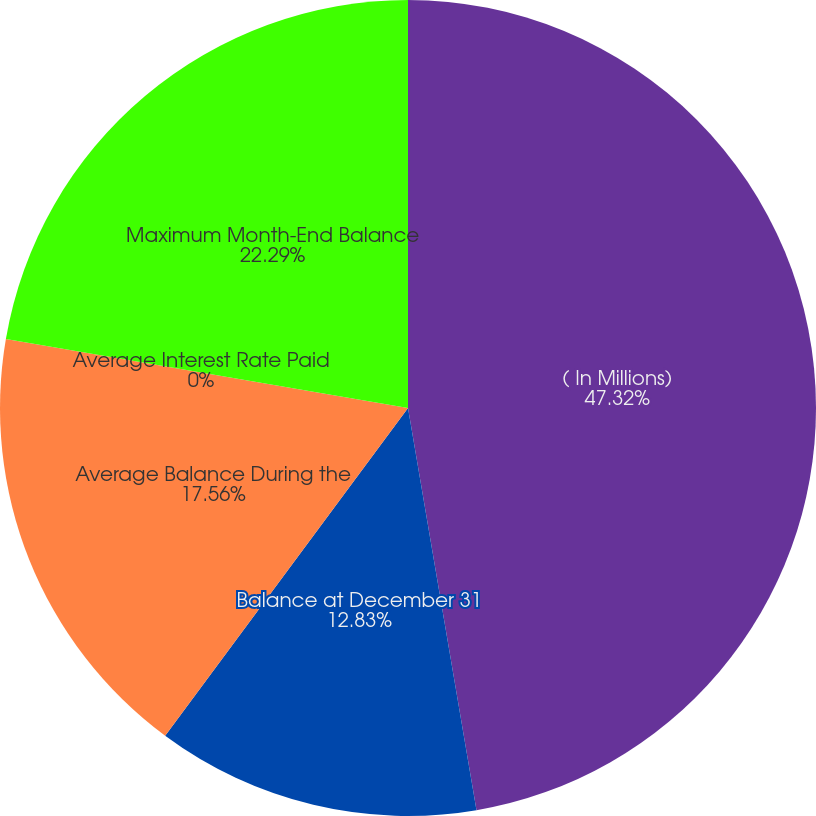Convert chart. <chart><loc_0><loc_0><loc_500><loc_500><pie_chart><fcel>( In Millions)<fcel>Balance at December 31<fcel>Average Balance During the<fcel>Average Interest Rate Paid<fcel>Maximum Month-End Balance<nl><fcel>47.31%<fcel>12.83%<fcel>17.56%<fcel>0.0%<fcel>22.29%<nl></chart> 